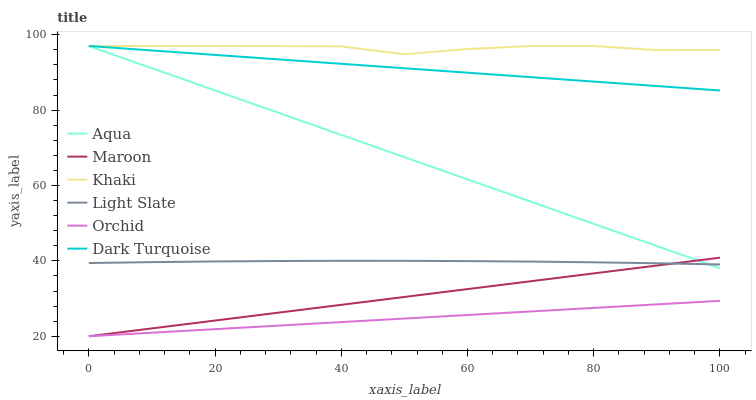Does Orchid have the minimum area under the curve?
Answer yes or no. Yes. Does Khaki have the maximum area under the curve?
Answer yes or no. Yes. Does Light Slate have the minimum area under the curve?
Answer yes or no. No. Does Light Slate have the maximum area under the curve?
Answer yes or no. No. Is Maroon the smoothest?
Answer yes or no. Yes. Is Khaki the roughest?
Answer yes or no. Yes. Is Light Slate the smoothest?
Answer yes or no. No. Is Light Slate the roughest?
Answer yes or no. No. Does Maroon have the lowest value?
Answer yes or no. Yes. Does Light Slate have the lowest value?
Answer yes or no. No. Does Aqua have the highest value?
Answer yes or no. Yes. Does Light Slate have the highest value?
Answer yes or no. No. Is Light Slate less than Khaki?
Answer yes or no. Yes. Is Aqua greater than Orchid?
Answer yes or no. Yes. Does Orchid intersect Maroon?
Answer yes or no. Yes. Is Orchid less than Maroon?
Answer yes or no. No. Is Orchid greater than Maroon?
Answer yes or no. No. Does Light Slate intersect Khaki?
Answer yes or no. No. 